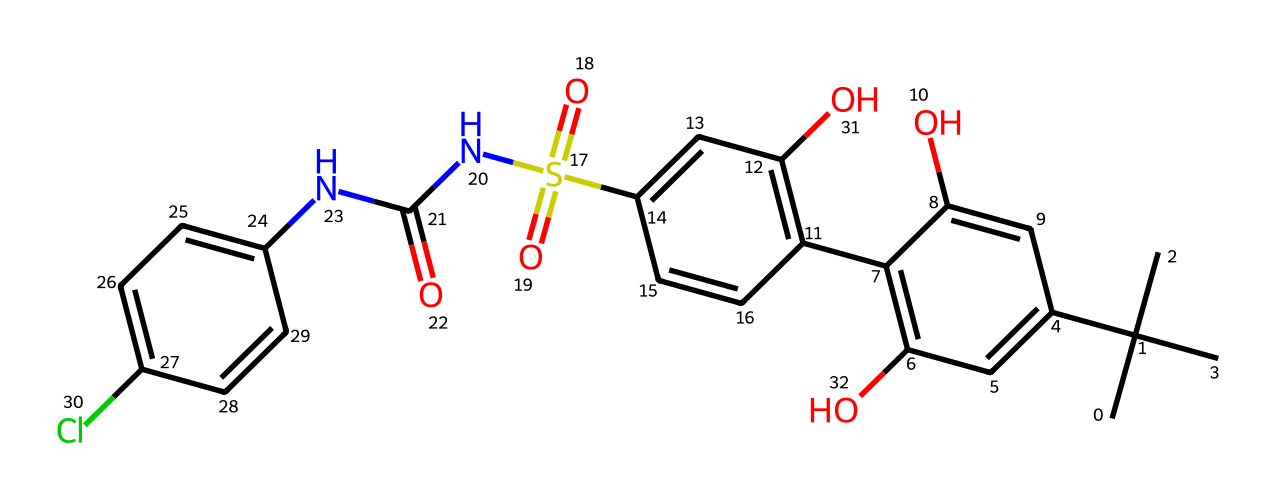What is the core structure of this compound? The core structure is characterized by the presence of a central aromatic ring system, indicated by the interconnected carbon atoms arranged in a hexagonal pattern. The multiple substituents of the aromatic rings define it as a complex rather than a simple compound.
Answer: aromatic rings How many nitrogen atoms are present in the molecular structure? The SMILES representation includes one nitrogen atom, which can be identified by the presence of the 'N' symbol. It is located within a functional group indicating an amide linkage.
Answer: one What type of functional groups can be identified in this compound? The compound features several functional groups, including hydroxyl (-OH), sulfonamide (-SO2-NH), and amide (-C(=O)N) groups. These distinctive groups are indicated by their respective symbols in the SMILES string, showcasing a diverse structural complexity.
Answer: hydroxyl, sulfonamide, amide How many total carbon atoms are there in the compound? By analyzing the SMILES string, we count the occurrences of 'C' and note that there are 20 carbon atoms indicated within the structure, including those in both the main skeleton and substituents.
Answer: twenty What does the presence of chlorine in the compound suggest about its properties? The chlorine atom, represented by 'Cl', suggests potential activity in biological systems due to its ability to engage in electronegative interactions and modify the compound's solubility and metabolic pathways, which could enhance potency or alter taste.
Answer: biological activity What is the significance of the sulfonyl group in this compound? The sulfonyl group, noted by 'S(=O)(=O)', plays a crucial role in enhancing the sweetness perception and allows for potential interactions with taste receptors, making it valuable in artificial sweeteners. The presence of two double-bonded oxygens contributes to its unique properties.
Answer: enhances sweetness 